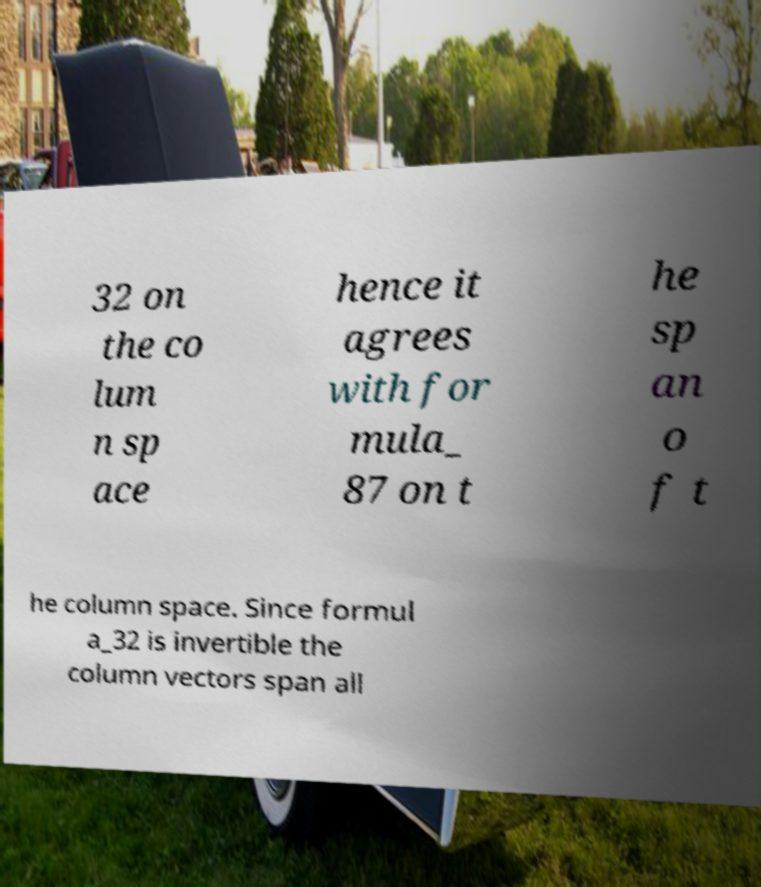Can you accurately transcribe the text from the provided image for me? 32 on the co lum n sp ace hence it agrees with for mula_ 87 on t he sp an o f t he column space. Since formul a_32 is invertible the column vectors span all 